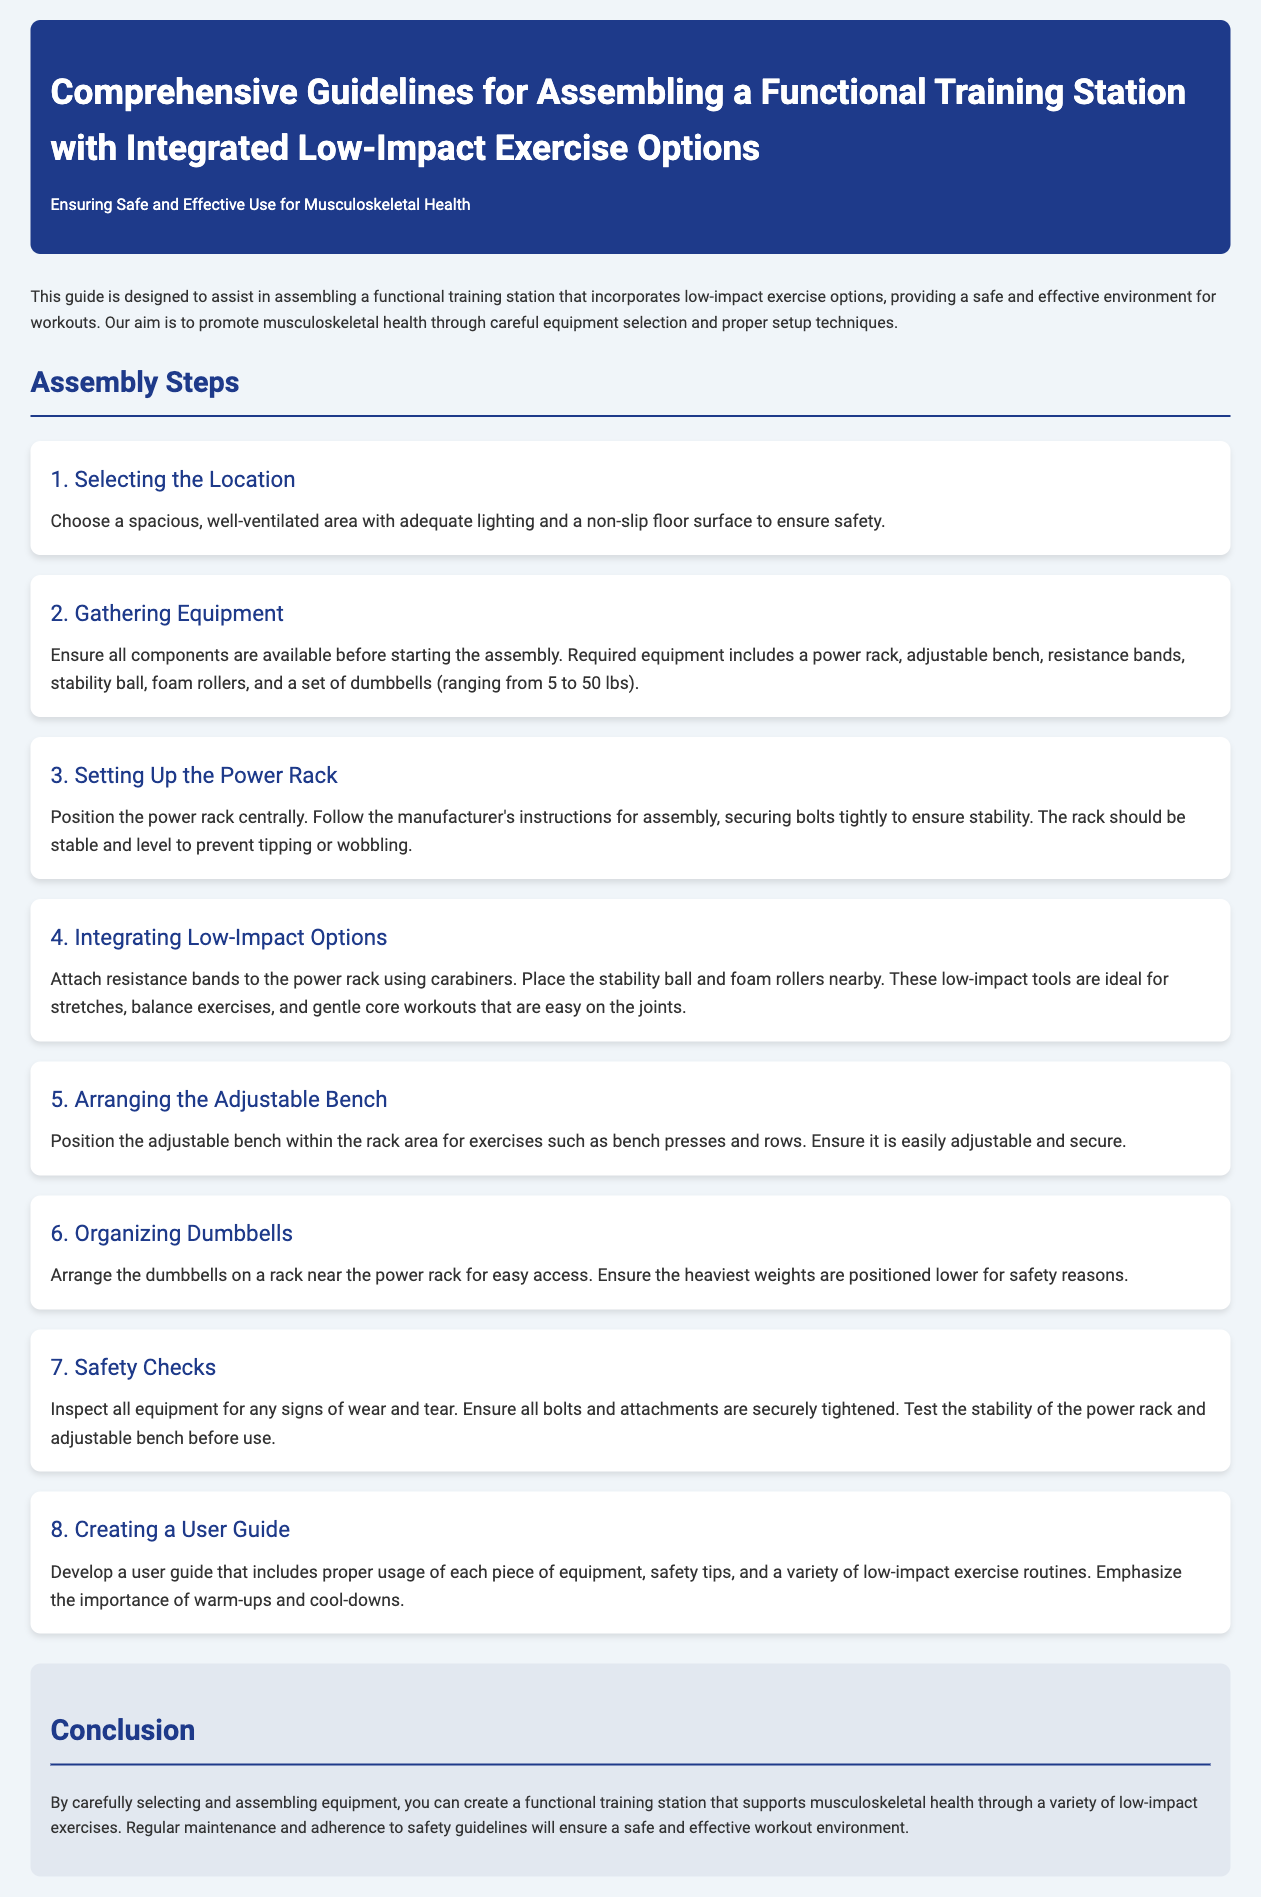What should you consider when selecting the location for assembly? The location should be spacious, well-ventilated, and have adequate lighting with a non-slip floor surface.
Answer: Spacious and non-slip What equipment is needed to assemble the training station? The required equipment includes a power rack, adjustable bench, resistance bands, stability ball, foam rollers, and dumbbells ranging from 5 to 50 lbs.
Answer: Power rack, adjustable bench, resistance bands, stability ball, foam rollers, dumbbells How many assembly steps are listed in the document? The document lists eight assembly steps for assembling the training station.
Answer: Eight What are the ideal uses for the stability ball and foam rollers? They are ideal for stretches, balance exercises, and gentle core workouts that are easy on the joints.
Answer: Stretches and balance exercises What should be done during safety checks? Inspect all equipment for wear and tear, ensure all bolts and attachments are securely tightened, and test the stability of the power rack and adjustable bench.
Answer: Inspect, tighten bolts, test stability What is the purpose of creating a user guide? The user guide includes proper usage of equipment, safety tips, and low-impact exercise routines, emphasizing warm-ups and cool-downs.
Answer: Proper usage and safety tips Where should the heaviest weights be positioned on the dumbbell rack? The heaviest weights should be positioned lower on the rack for safety reasons.
Answer: Positioned lower How can you ensure a safe workout environment? Regular maintenance and adherence to safety guidelines will ensure a safe and effective workout environment.
Answer: Maintenance and safety guidelines 